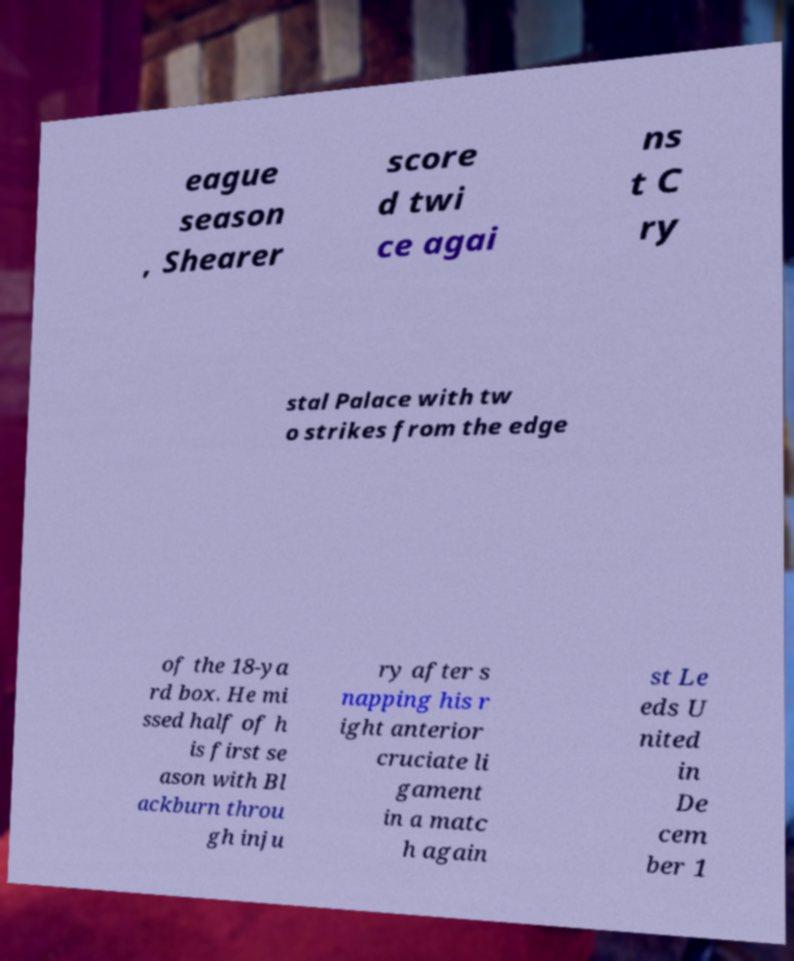There's text embedded in this image that I need extracted. Can you transcribe it verbatim? eague season , Shearer score d twi ce agai ns t C ry stal Palace with tw o strikes from the edge of the 18-ya rd box. He mi ssed half of h is first se ason with Bl ackburn throu gh inju ry after s napping his r ight anterior cruciate li gament in a matc h again st Le eds U nited in De cem ber 1 